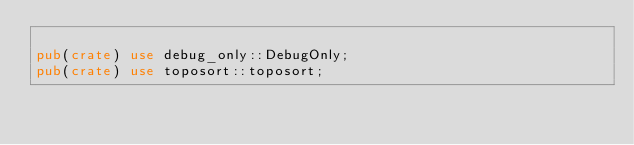Convert code to text. <code><loc_0><loc_0><loc_500><loc_500><_Rust_>
pub(crate) use debug_only::DebugOnly;
pub(crate) use toposort::toposort;
</code> 